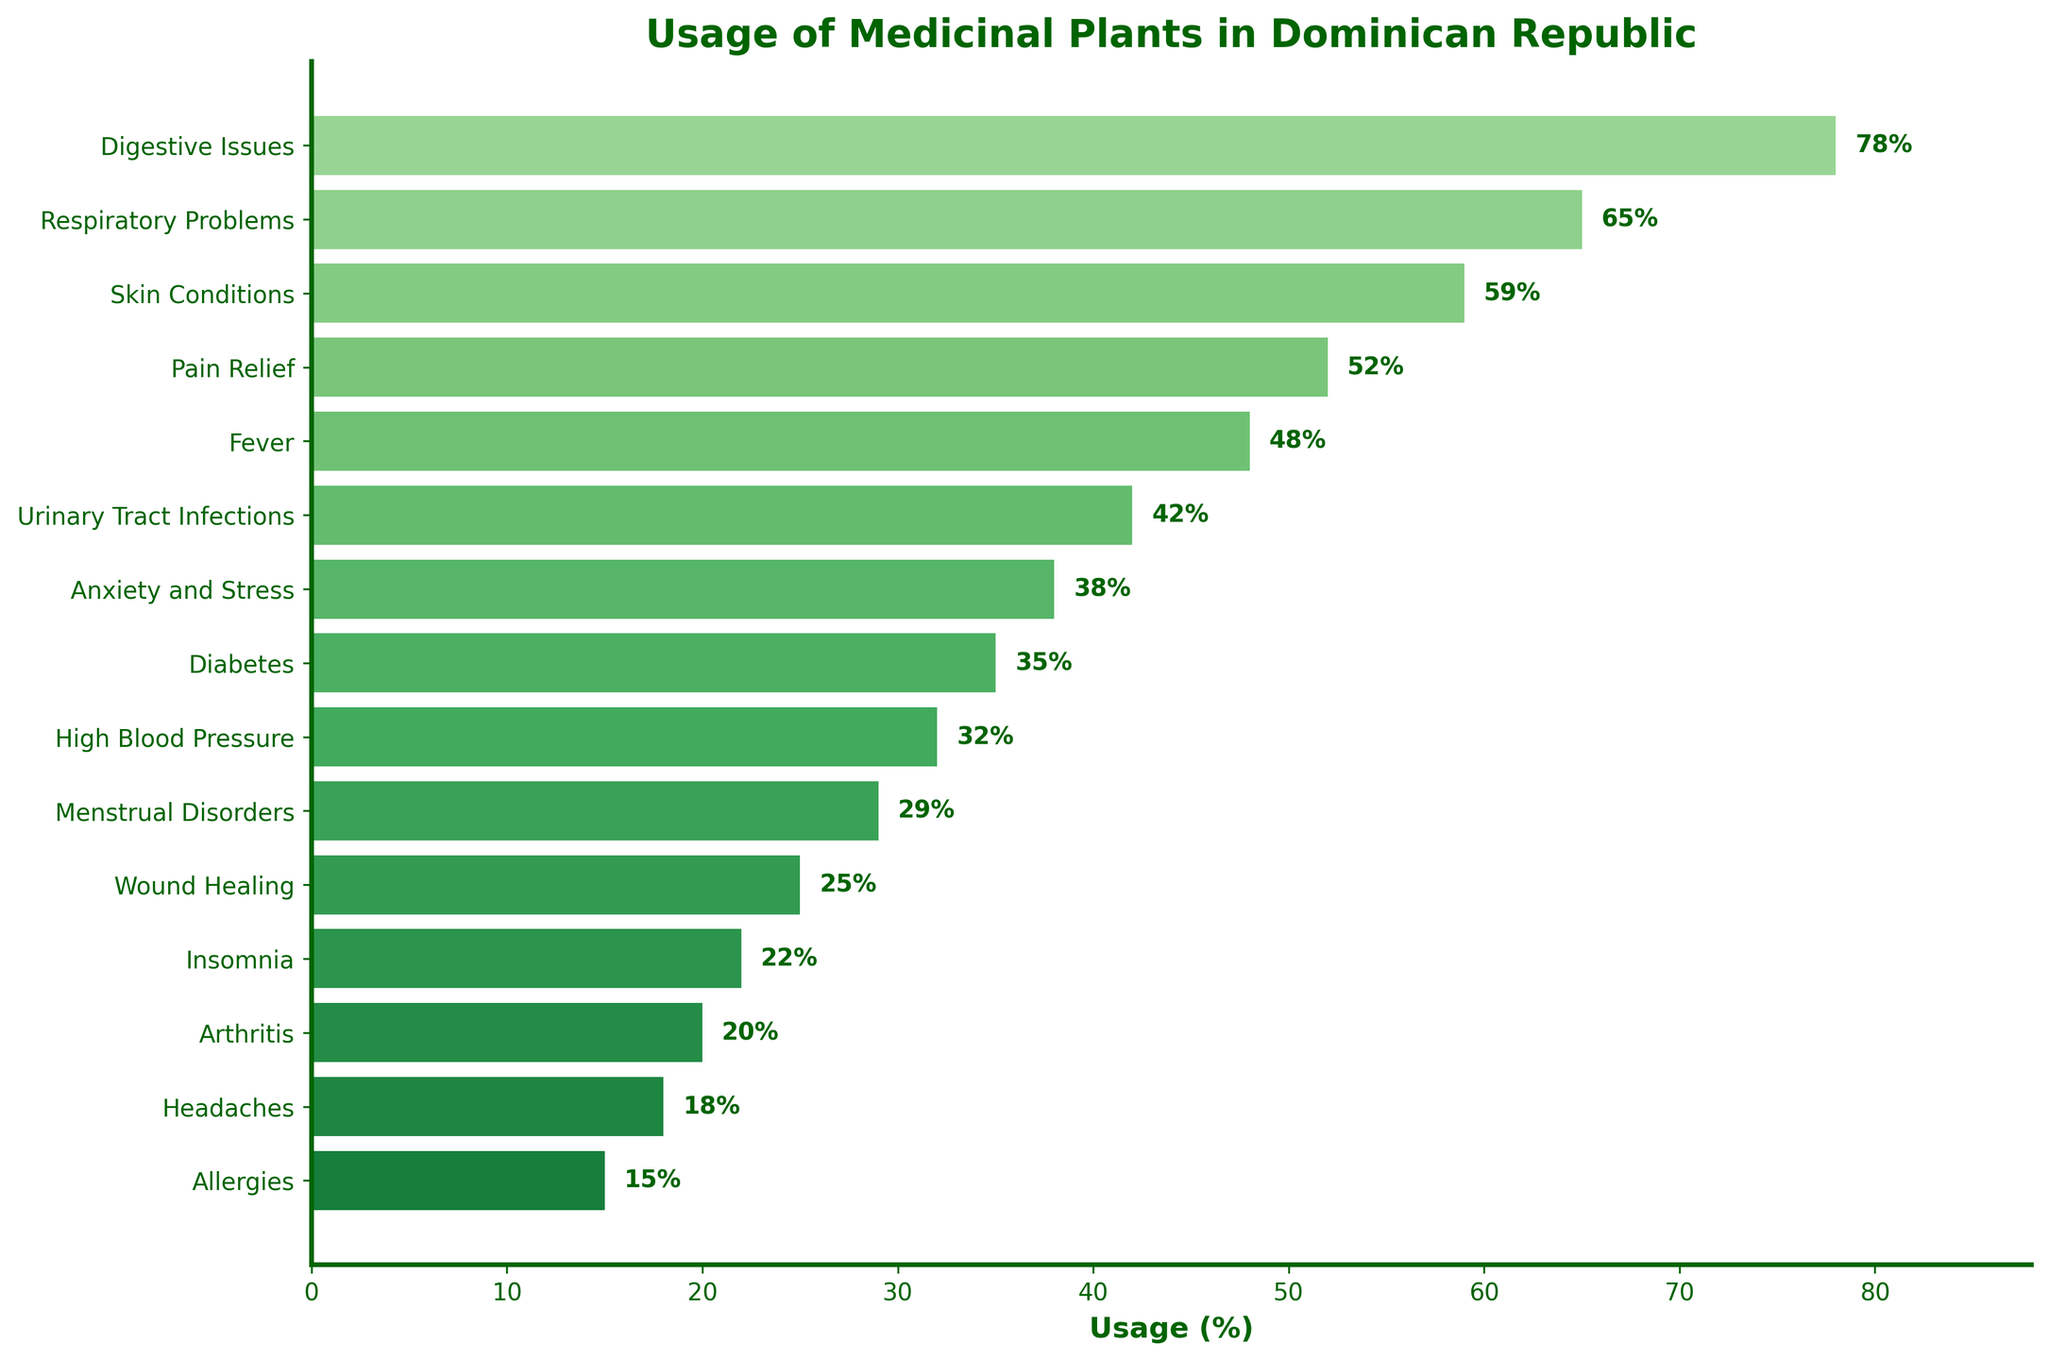what is the usage percentage of medicinal plants for digestive issues? Digestive Issues has a bar extending to 78%, so the usage percentage for digestive issues is 78%.
Answer: 78% which two ailments have the closest usage percentages? Urinary Tract Infections (42%) and Anxiety and Stress (38%) have the closest usage percentages with a difference of 4%.
Answer: Urinary Tract Infections and Anxiety and Stress compare the usage percentage of medicinal plants for headaches and menstrual disorders Headaches has a usage percentage of 18% while Menstrual Disorders has a usage percentage of 29%. Therefore, Menstrual Disorders have a greater usage percentage than Headaches.
Answer: menstrual Disorders > headaches what is the color and length of the bar representing respiratory problems? The bar representing respiratory problems is of medium length (65%) and is colored green.
Answer: green, 65% calculate the average usage percentage for the top five ailments The top five ailments and their usage percentages are Digestive Issues (78%), Respiratory Problems (65%), Skin Conditions (59%), Pain Relief (52%), and Fever (48%). The average is calculated as (78 + 65 + 59 + 52 + 48) / 5 = 60.4.
Answer: 60.4% how many ailments have a usage percentage above 50%? The ailments above 50% usage percentage are Digestive Issues (78%), Respiratory Problems (65%), Skin Conditions (59%), and Pain Relief (52%), making a total of four ailments.
Answer: 4 which ailment has the lowest usage percentage of medicinal plants and what is it? Allergies have the lowest usage percentage with a bar ending at 15%.
Answer: allergies, 15% what is the total usage percentage for diabetes and high blood pressure combined? The usage percentage for diabetes is 35% and for high blood pressure is 32%, so the total is 35% + 32% = 67%.
Answer: 67% compare the usage percentages of skin conditions and headaches Skin Conditions has a usage percentage of 59%, while Headaches have a usage percentage of 18%. Hence, Skin Conditions have a much higher usage percentage than Headaches.
Answer: skin conditions > headaches which visual attribute signifies the category with the second highest usage percentage? The category with the second-highest usage percentage is Respiratory problems (65%), which has the second longest green bar from the top.
Answer: medium green bar, second longest 